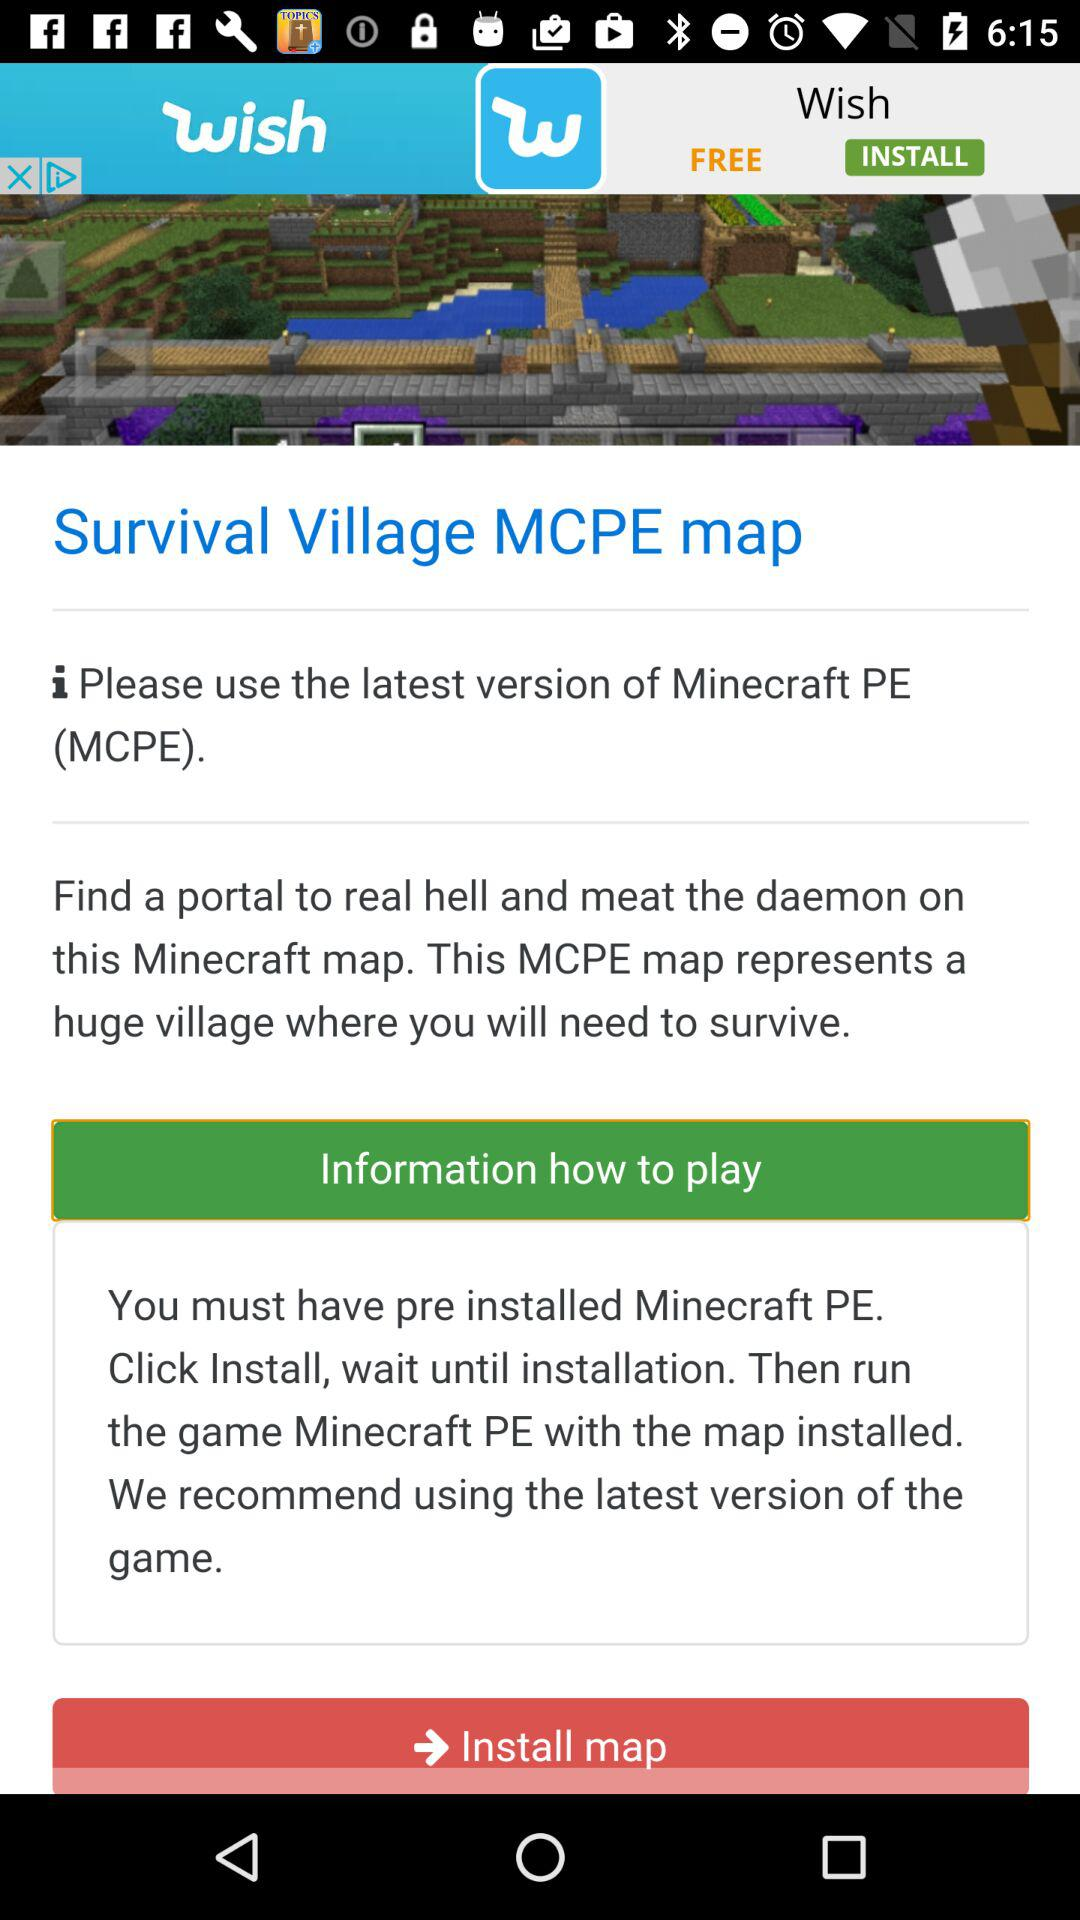What is the name of the application? The name of the application is "Survival Village MCPE map". 